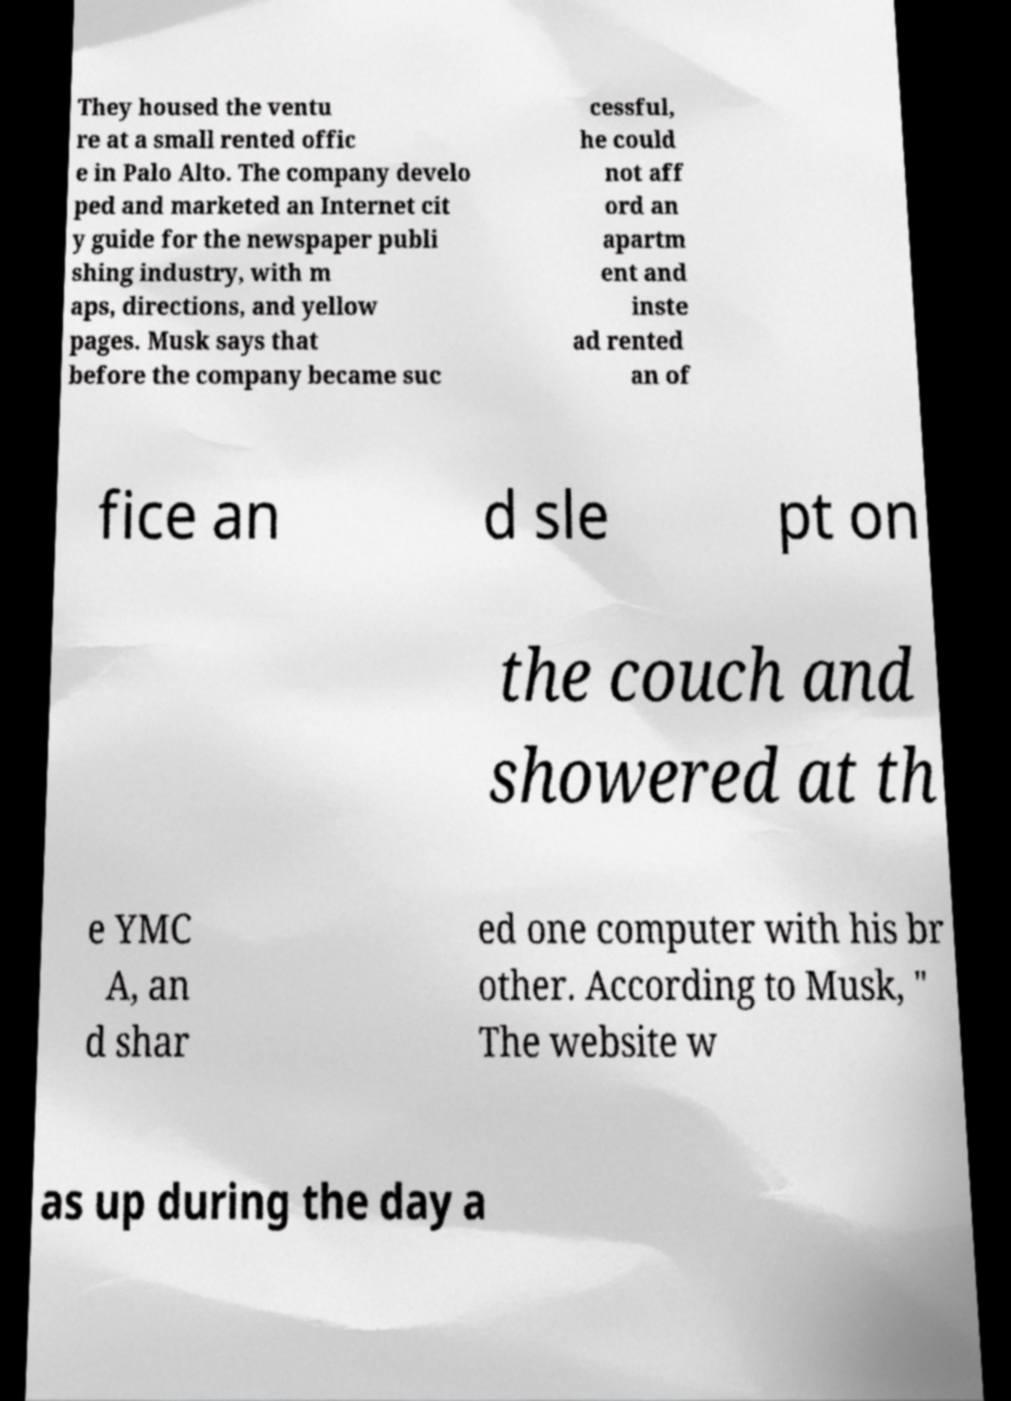Can you read and provide the text displayed in the image?This photo seems to have some interesting text. Can you extract and type it out for me? They housed the ventu re at a small rented offic e in Palo Alto. The company develo ped and marketed an Internet cit y guide for the newspaper publi shing industry, with m aps, directions, and yellow pages. Musk says that before the company became suc cessful, he could not aff ord an apartm ent and inste ad rented an of fice an d sle pt on the couch and showered at th e YMC A, an d shar ed one computer with his br other. According to Musk, " The website w as up during the day a 